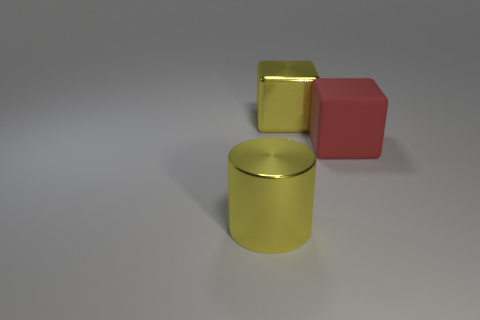Add 3 red matte blocks. How many objects exist? 6 Subtract all blocks. How many objects are left? 1 Subtract all shiny cylinders. Subtract all yellow metallic cylinders. How many objects are left? 1 Add 2 large yellow cylinders. How many large yellow cylinders are left? 3 Add 2 metal cylinders. How many metal cylinders exist? 3 Subtract 0 cyan blocks. How many objects are left? 3 